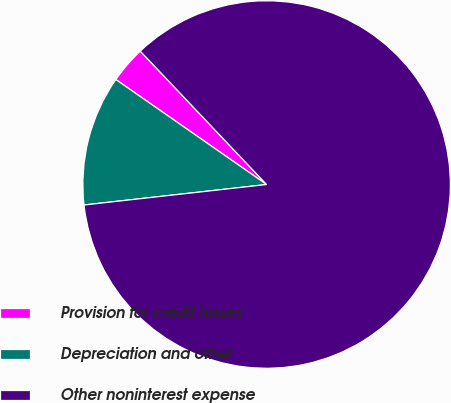Convert chart. <chart><loc_0><loc_0><loc_500><loc_500><pie_chart><fcel>Provision for credit losses<fcel>Depreciation and other<fcel>Other noninterest expense<nl><fcel>3.25%<fcel>11.46%<fcel>85.29%<nl></chart> 